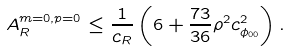<formula> <loc_0><loc_0><loc_500><loc_500>A ^ { m = 0 , p = 0 } _ { R } \leq \frac { 1 } { c _ { R } } \left ( 6 + \frac { 7 3 } { 3 6 } \rho ^ { 2 } c _ { \phi _ { 0 0 } } ^ { 2 } \right ) .</formula> 